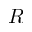<formula> <loc_0><loc_0><loc_500><loc_500>R</formula> 